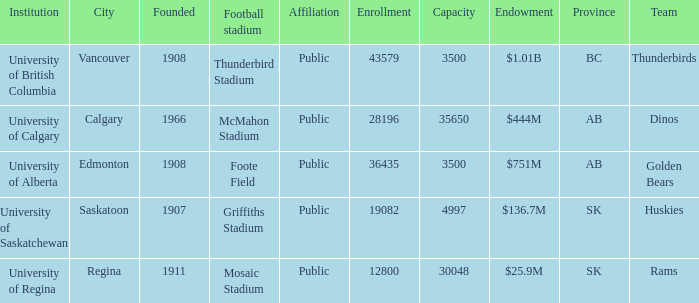What year was mcmahon stadium founded? 1966.0. 